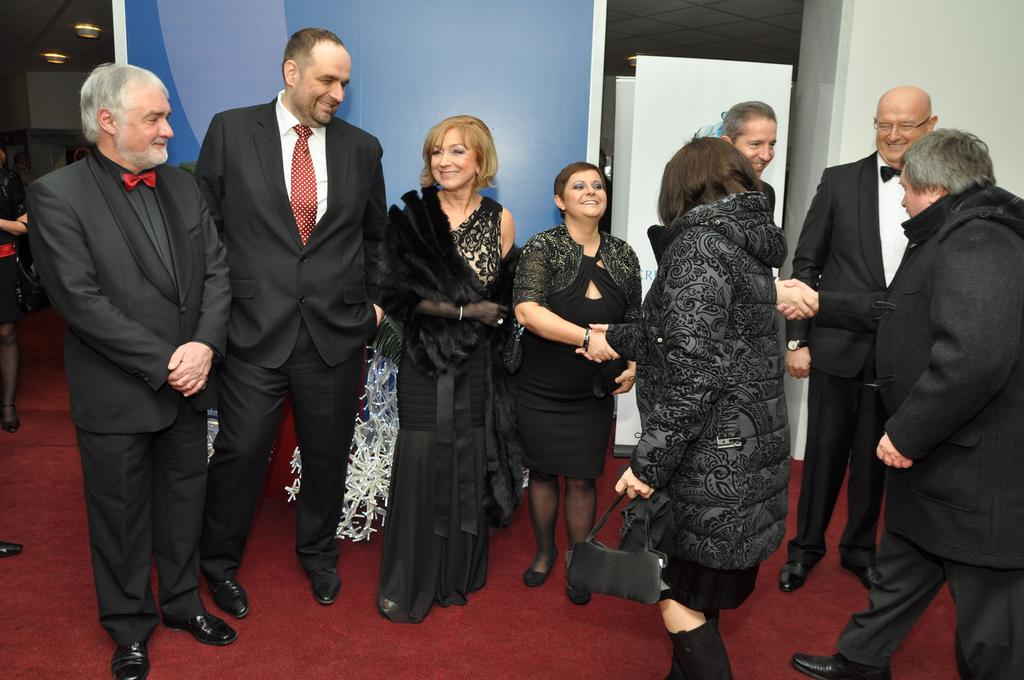What is the main subject of the image? The main subject of the image is people standing on a carpet. What can be seen in the background of the image? There is a banner in the background of the image. What type of surface is visible in the image? There is a wall visible in the image. What type of drug is being advertised on the flag in the image? There is no flag present in the image, and therefore no drug can be advertised on it. 